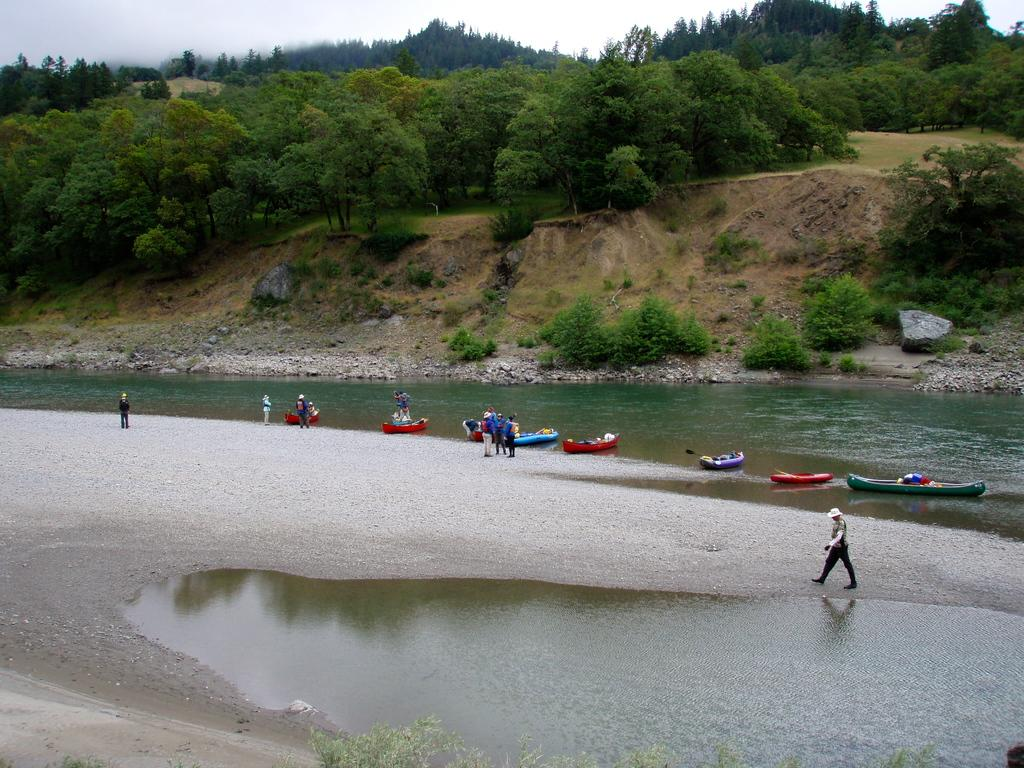What is the main subject of the image? The main subject of the image is a lake. What can be seen in the lake? There are boats in the lake. Are there any people in the image? Yes, there are people near the lake. What is located near the lake? There is a hill in the image. What types of vegetation are present on the hill? The hill has plants and trees on it. What type of shirt is the scarecrow wearing in the image? There is no scarecrow present in the image, so it is not possible to determine what type of shirt it might be wearing. 